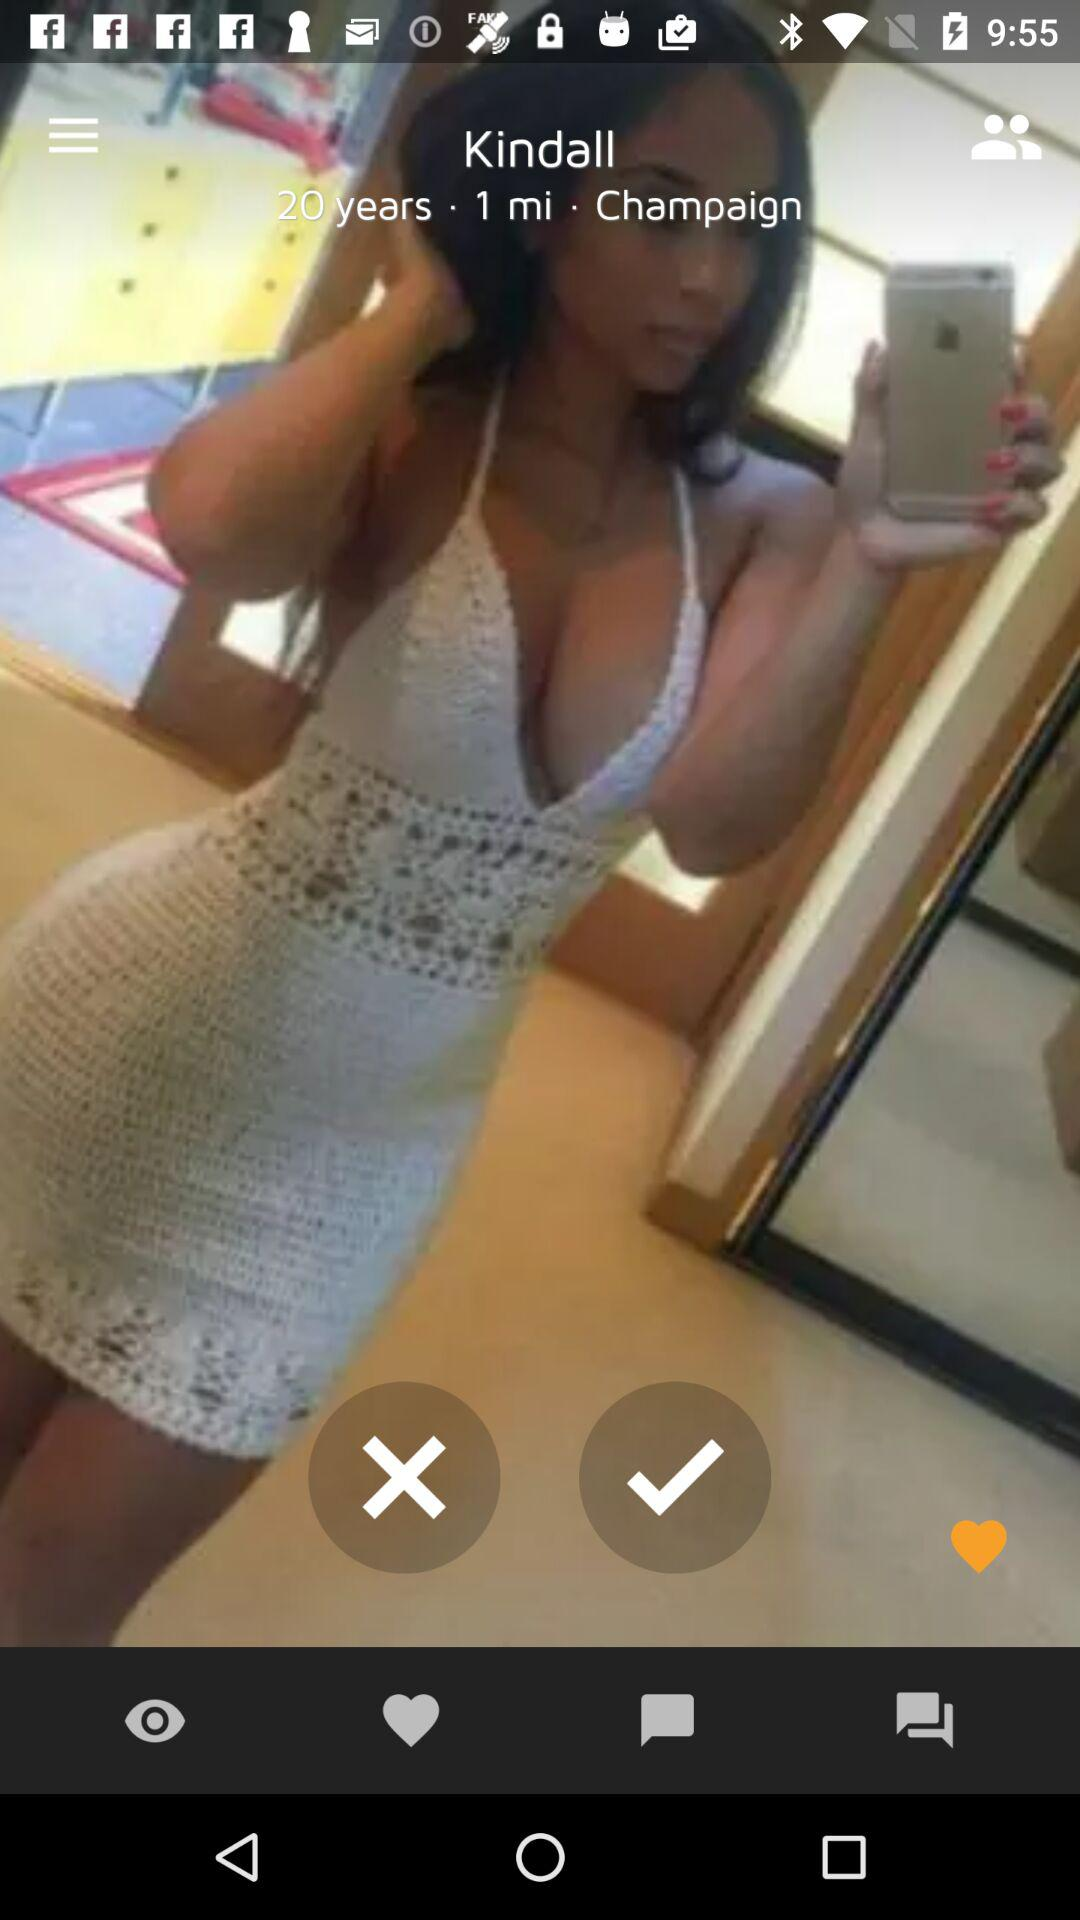What's the name of the user? The name of the user is Kindall. 